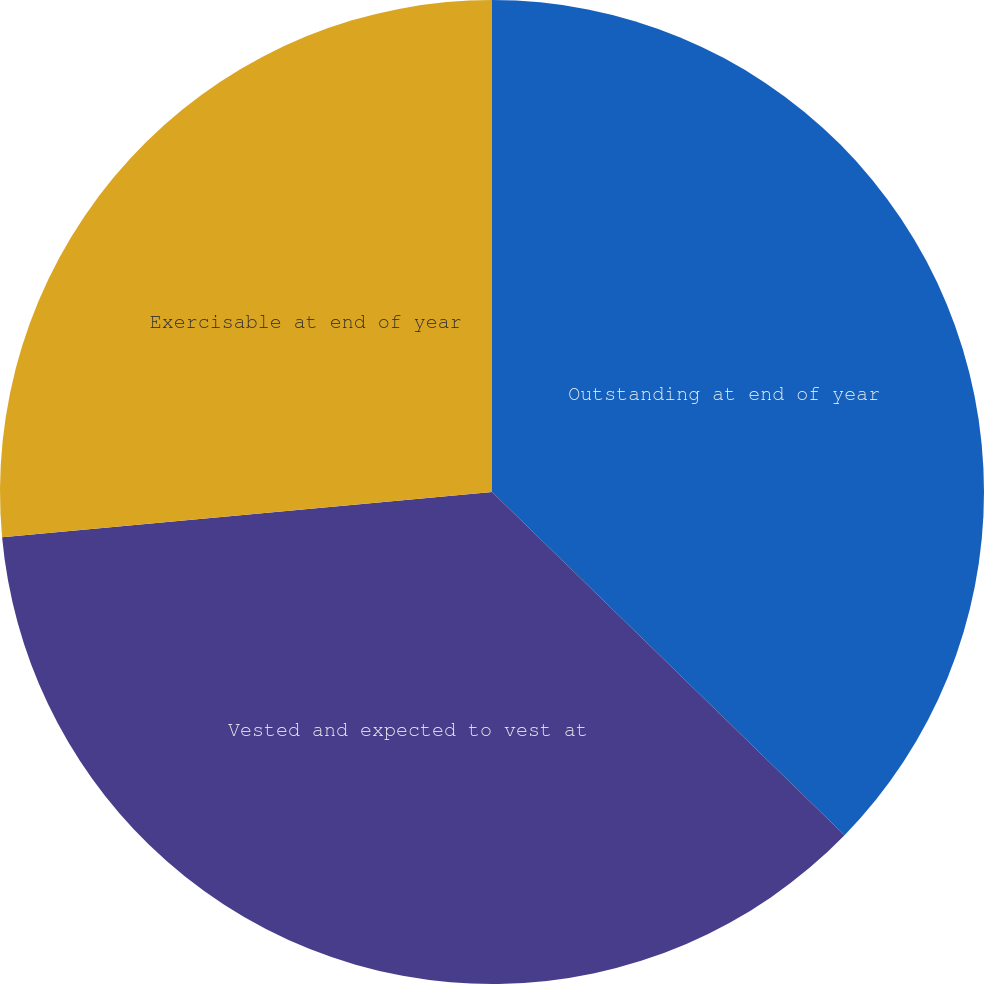Convert chart to OTSL. <chart><loc_0><loc_0><loc_500><loc_500><pie_chart><fcel>Outstanding at end of year<fcel>Vested and expected to vest at<fcel>Exercisable at end of year<nl><fcel>37.29%<fcel>36.25%<fcel>26.47%<nl></chart> 